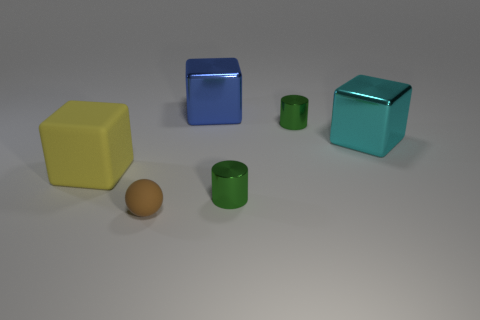Are there any other things that are the same size as the blue metal cube?
Ensure brevity in your answer.  Yes. The other big metal thing that is the same shape as the cyan thing is what color?
Ensure brevity in your answer.  Blue. Is there a cyan metal thing of the same shape as the small brown object?
Your answer should be very brief. No. What number of large cyan objects are behind the small metal thing that is behind the green metal cylinder that is in front of the big yellow matte thing?
Provide a short and direct response. 0. What number of things are either rubber things that are to the left of the tiny brown rubber thing or things in front of the yellow thing?
Provide a succinct answer. 3. Are there more blue objects behind the blue block than tiny brown balls that are on the left side of the tiny brown matte ball?
Your response must be concise. No. What material is the object right of the cylinder that is behind the thing that is to the left of the brown matte ball?
Your answer should be compact. Metal. There is a large thing to the left of the tiny brown sphere; does it have the same shape as the large blue thing to the right of the yellow rubber object?
Make the answer very short. Yes. Are there any blocks of the same size as the brown rubber thing?
Offer a terse response. No. How many yellow objects are metal blocks or matte blocks?
Your answer should be compact. 1. 